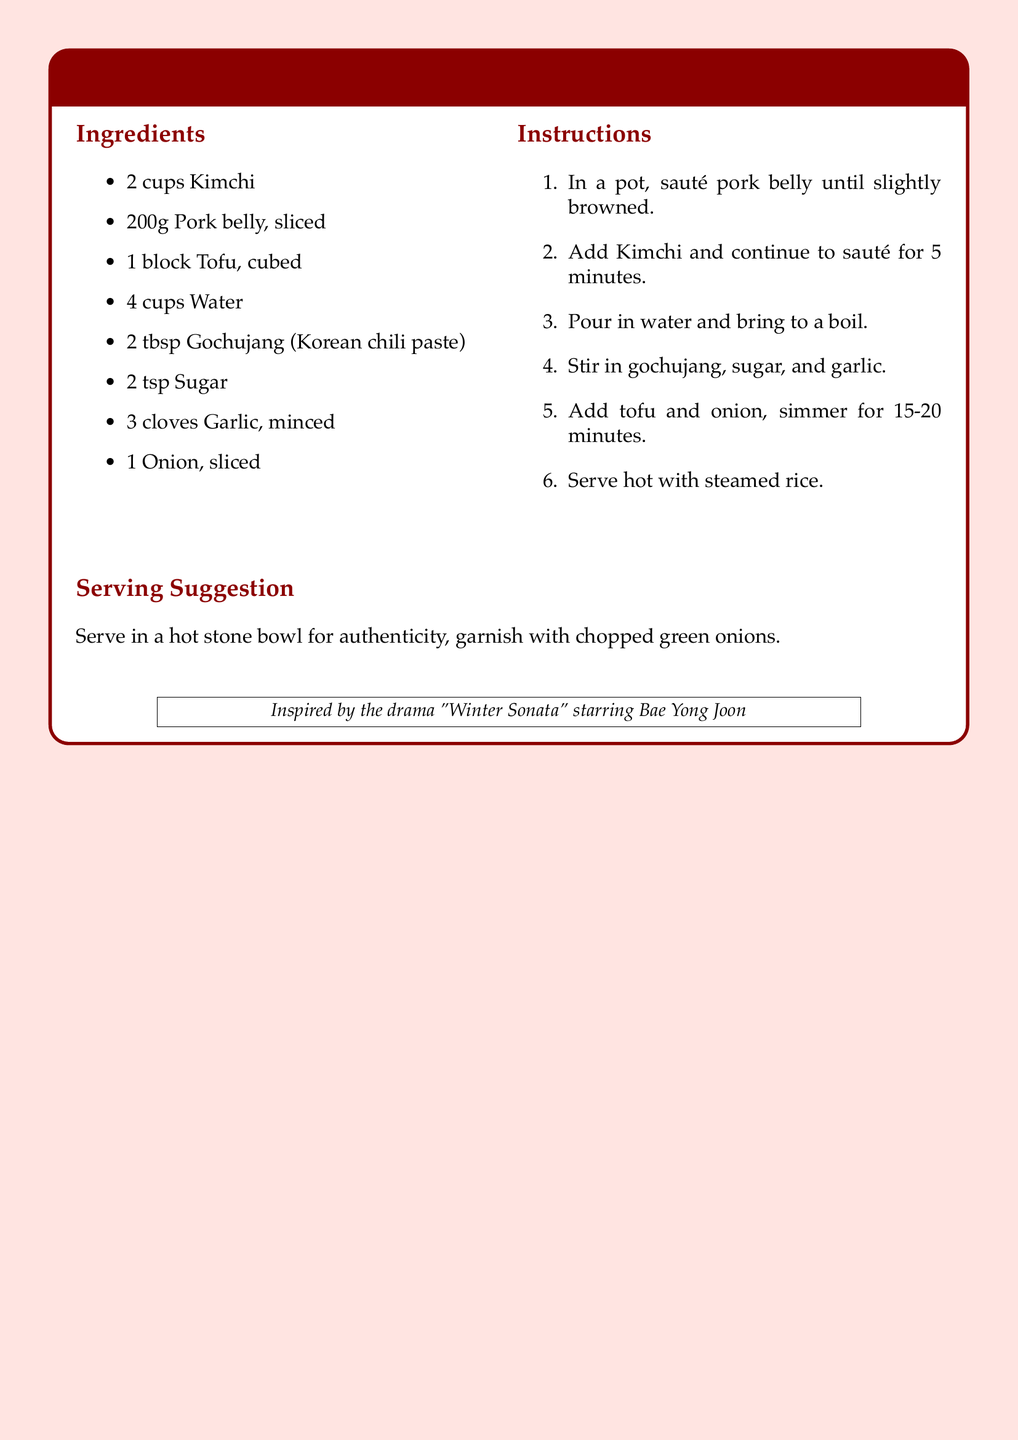What is the name of the recipe? The title of the recipe provided in the document is prominently displayed at the top of the tcolorbox.
Answer: Kimchi Jjigae What is the main protein ingredient used in this recipe? The ingredients list specifies that pork belly is included in the dish.
Answer: Pork belly How many cups of kimchi are required? The ingredients list states that 2 cups of kimchi are needed for the recipe.
Answer: 2 cups How long should the dish simmer? The instructions indicate that the dish needs to simmer for 15-20 minutes.
Answer: 15-20 minutes What is the cooking method for the pork belly? The instructions describe the initial step as sautéing the pork belly until browned.
Answer: Sauté What is the final serving suggestion for the dish? The document provides a serving suggestion that mentions serving the dish in a hot stone bowl.
Answer: Hot stone bowl Which drama inspired this recipe? The inspiration for the recipe is cited in a boxed note at the bottom of the document.
Answer: Winter Sonata How many cloves of garlic are used in the recipe? The ingredients list specifies that 3 cloves of garlic are required for this dish.
Answer: 3 cloves What color is used for the background of the document? The background color of the document is described in the styling section as light pink.
Answer: Light pink 